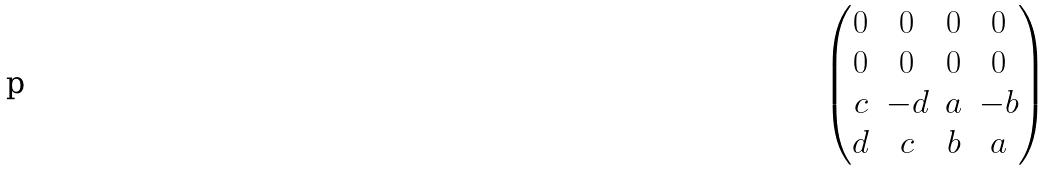Convert formula to latex. <formula><loc_0><loc_0><loc_500><loc_500>\begin{pmatrix} 0 & 0 & 0 & 0 \\ 0 & 0 & 0 & 0 \\ c & - d & a & - b \\ d & c & b & a \\ \end{pmatrix}</formula> 